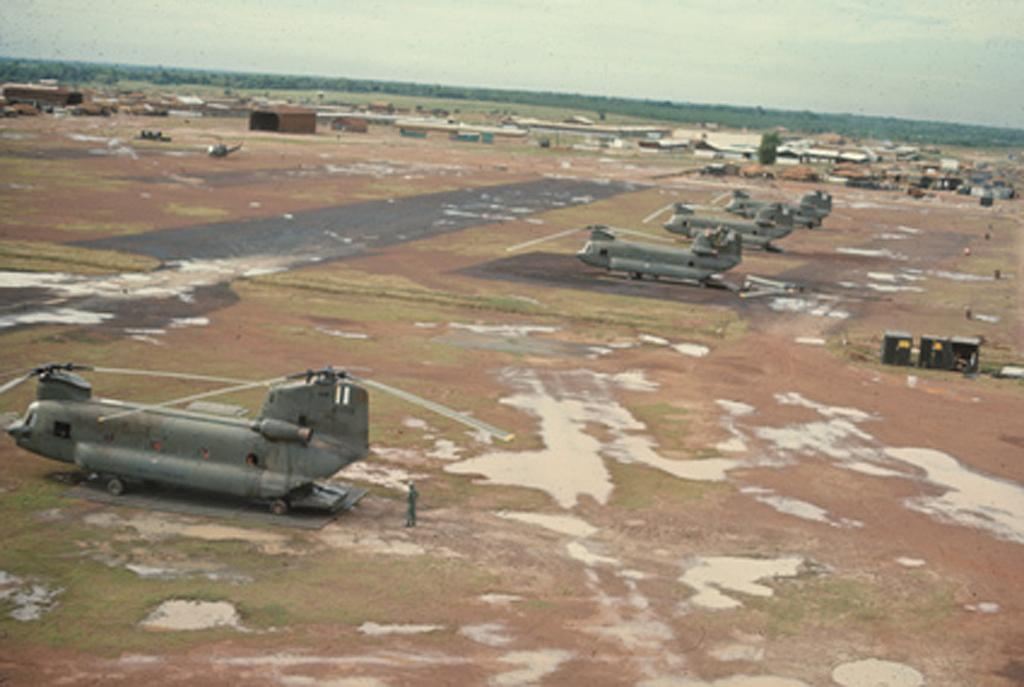What is the main subject of the image? The main subject of the image is planes. What other objects can be seen in the image? There are boxes in the image. What can be seen in the background of the image? There are trees in the background of the image. What is visible at the top of the image? The sky is visible at the top of the image. Can you see any fangs on the planes in the image? There are no fangs present on the planes in the image, as planes do not have teeth or any other features resembling fangs. 